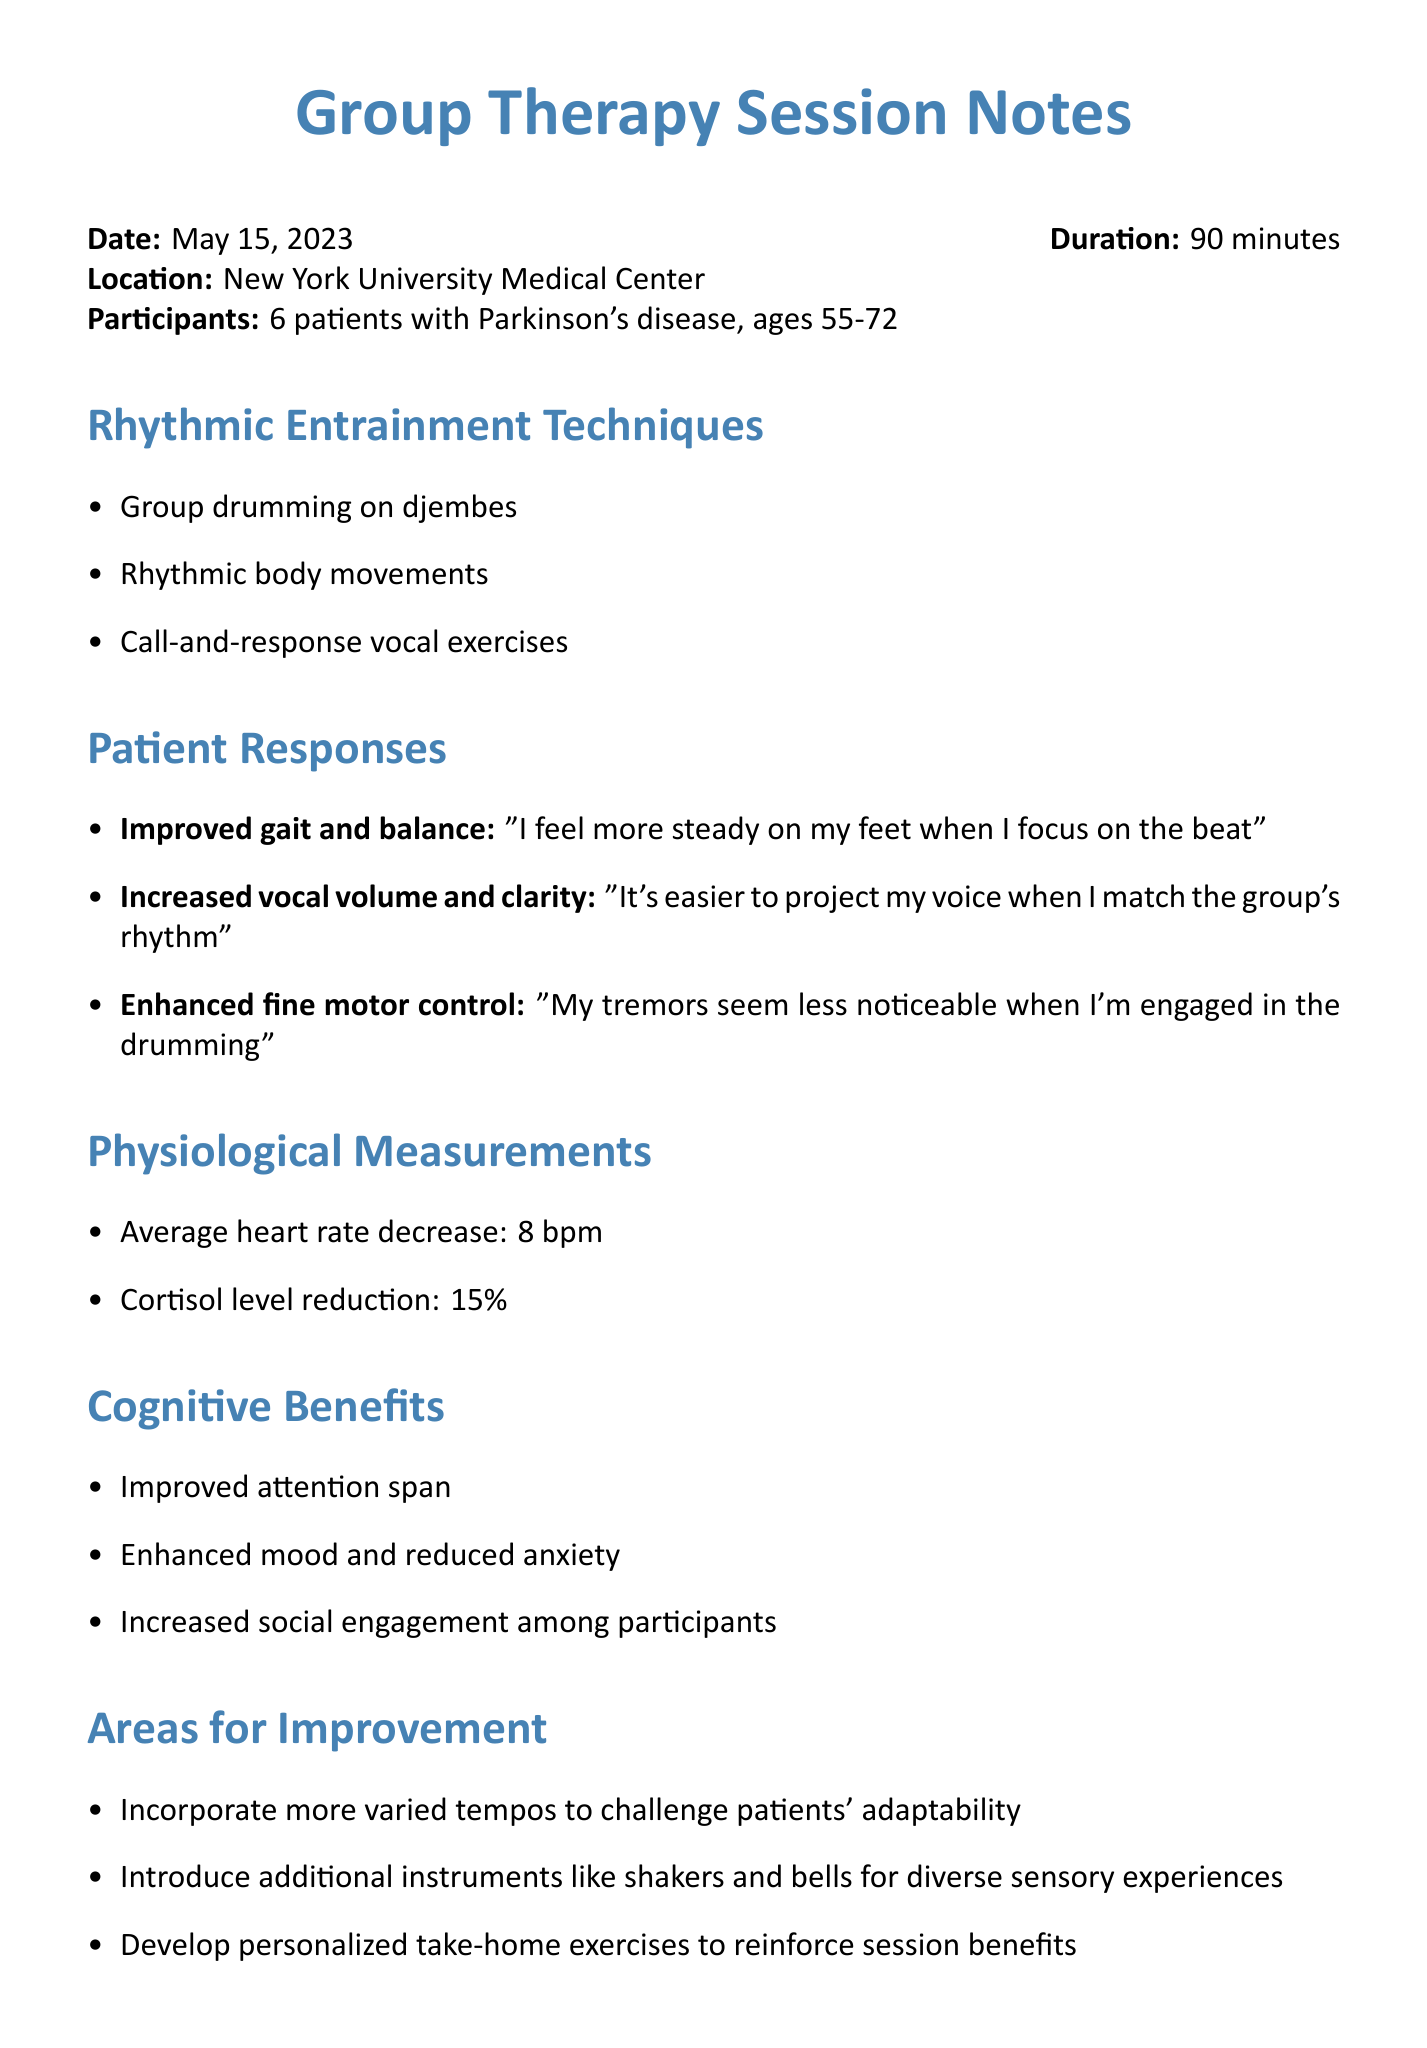what is the date of the session? The date of the session is explicitly stated in the document.
Answer: May 15, 2023 how long did the session last? The duration of the session is mentioned in the document.
Answer: 90 minutes how many patients participated in the session? The document specifies the number of patients in the session.
Answer: 6 patients what was one observation related to vocal activities? The document includes patient responses regarding vocal clarity during singing activities.
Answer: Increased vocal volume and clarity during singing activities which rhythmic entrainment technique involves using instruments? The document lists various techniques, including drumming.
Answer: Group drumming on djembes how much did the average heart rate decrease? The document provides specific physiological measurements regarding heart rate.
Answer: 8 bpm what is one area identified for improvement? The document outlines areas for improving the therapy sessions.
Answer: Incorporate more varied tempos what was one cognitive benefit observed among participants? The cognitive benefits are listed in the document, highlighting one aspect.
Answer: Improved attention span what is the location of the therapy session? The document clearly states where the session took place.
Answer: New York University Medical Center 